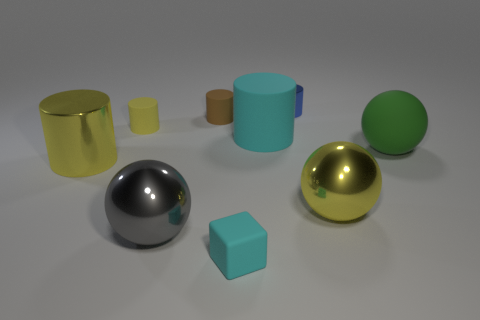How many yellow cylinders must be subtracted to get 1 yellow cylinders? 1 Subtract all brown rubber cylinders. How many cylinders are left? 4 Add 1 tiny blue shiny spheres. How many objects exist? 10 Subtract all blue cylinders. How many cylinders are left? 4 Subtract all red balls. How many yellow cylinders are left? 2 Subtract all cubes. How many objects are left? 8 Subtract 1 cubes. How many cubes are left? 0 Add 7 green matte objects. How many green matte objects exist? 8 Subtract 1 gray balls. How many objects are left? 8 Subtract all red cylinders. Subtract all cyan cubes. How many cylinders are left? 5 